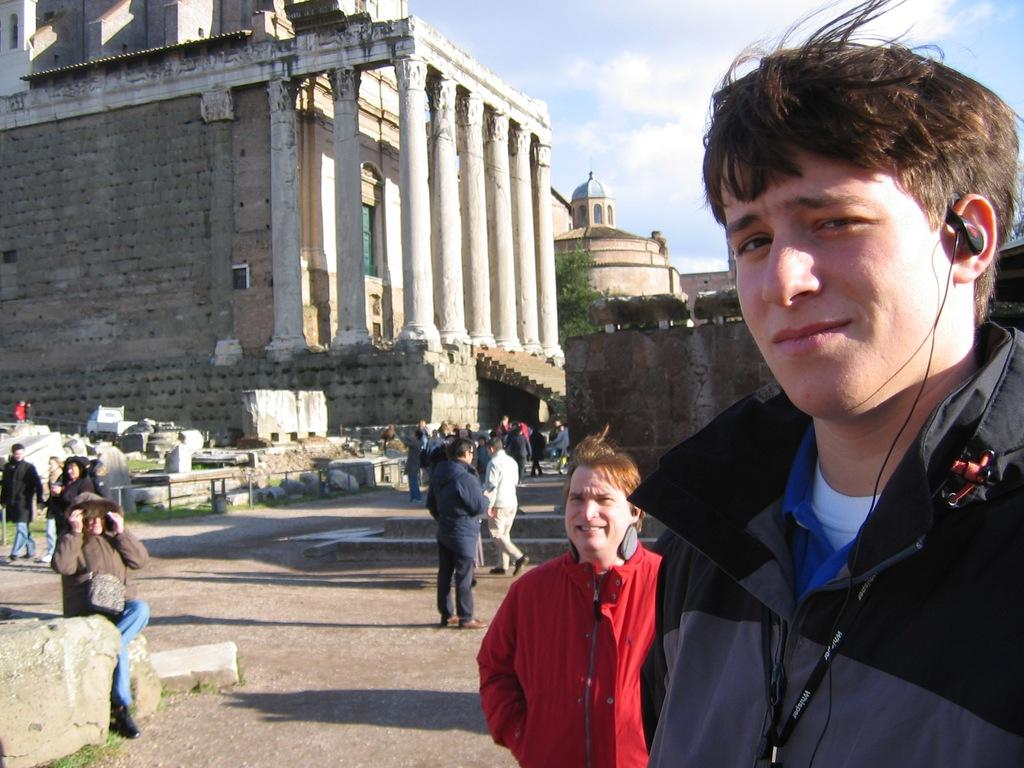What can be seen on the walkway in the image? There are groups of people on the walkway. What is visible in the background of the image? There are buildings, a tree, and the sky in the background. Can you describe the left side of the image? There are rocks on the left side of the image. What type of lamp is hanging from the tree in the image? There is no lamp hanging from the tree in the image; it only features a tree and other background elements. How many towns are visible in the image? There is no town present in the image; it only shows a walkway, groups of people, and background elements. 